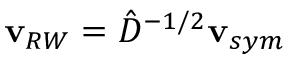<formula> <loc_0><loc_0><loc_500><loc_500>v _ { R W } = \hat { D } ^ { - 1 / 2 } v _ { s y m }</formula> 